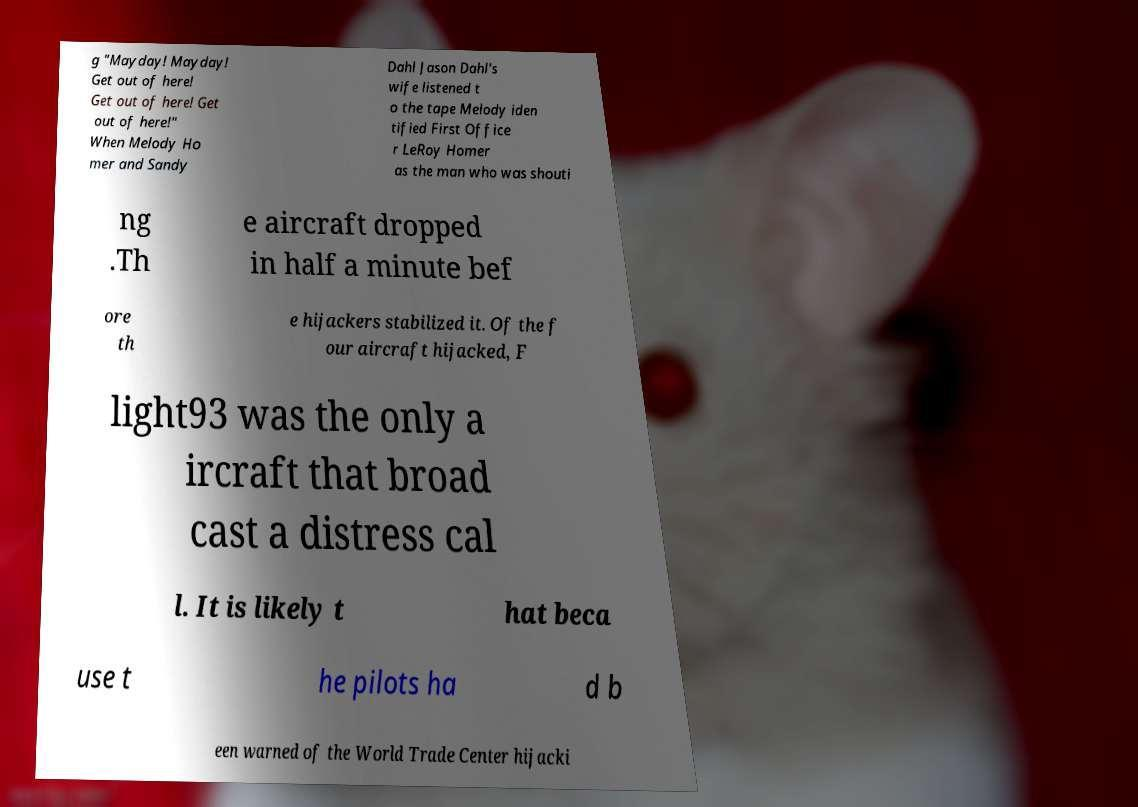Can you read and provide the text displayed in the image?This photo seems to have some interesting text. Can you extract and type it out for me? g "Mayday! Mayday! Get out of here! Get out of here! Get out of here!" When Melody Ho mer and Sandy Dahl Jason Dahl's wife listened t o the tape Melody iden tified First Office r LeRoy Homer as the man who was shouti ng .Th e aircraft dropped in half a minute bef ore th e hijackers stabilized it. Of the f our aircraft hijacked, F light93 was the only a ircraft that broad cast a distress cal l. It is likely t hat beca use t he pilots ha d b een warned of the World Trade Center hijacki 